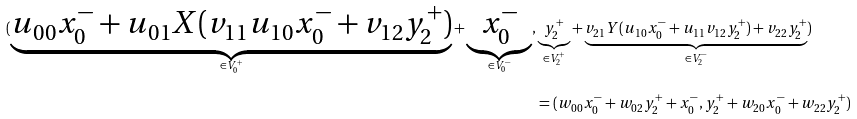<formula> <loc_0><loc_0><loc_500><loc_500>( \underbrace { u _ { 0 0 } x _ { 0 } ^ { - } + u _ { 0 1 } X ( v _ { 1 1 } u _ { 1 0 } x _ { 0 } ^ { - } + v _ { 1 2 } y _ { 2 } ^ { + } ) } _ { \in V _ { 0 } ^ { + } } + \underbrace { x _ { 0 } ^ { - } } _ { \in V _ { 0 } ^ { - } } , & \underbrace { y _ { 2 } ^ { + } } _ { \in V _ { 2 } ^ { + } } + \underbrace { v _ { 2 1 } Y ( u _ { 1 0 } x _ { 0 } ^ { - } + u _ { 1 1 } v _ { 1 2 } y _ { 2 } ^ { + } ) + v _ { 2 2 } y _ { 2 } ^ { + } } _ { \in V _ { 2 } ^ { - } } ) \\ & = ( w _ { 0 0 } x _ { 0 } ^ { - } + w _ { 0 2 } y _ { 2 } ^ { + } + x _ { 0 } ^ { - } , y _ { 2 } ^ { + } + w _ { 2 0 } x _ { 0 } ^ { - } + w _ { 2 2 } y _ { 2 } ^ { + } )</formula> 